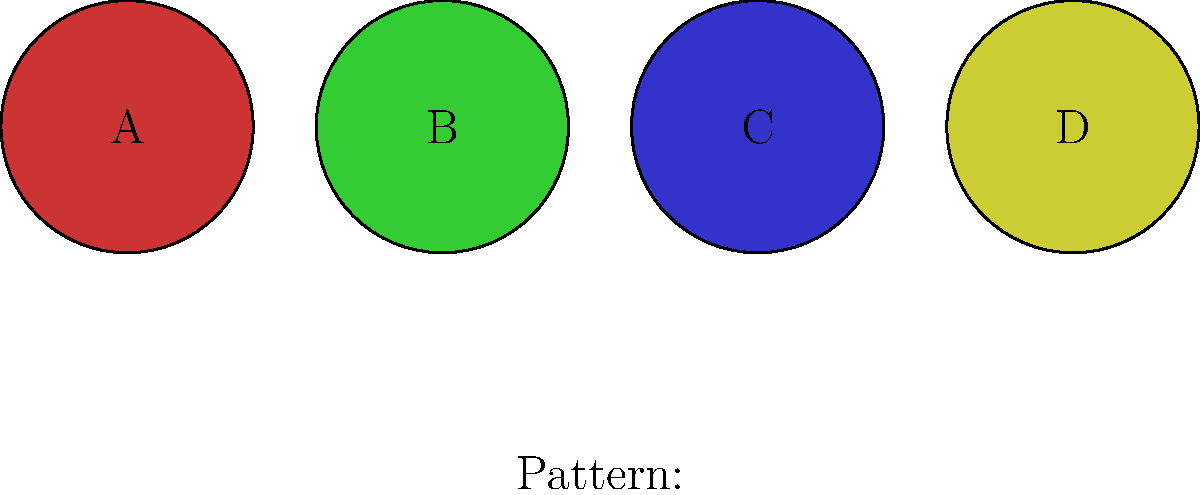As you're designing a new collection for your online boutique, you need to create a striped fabric pattern using the swatches shown above. Which sequence of swatches will produce the pattern shown below the individual swatches? To determine the correct sequence of fabric swatches, we need to analyze the pattern shown and match it with the given swatches:

1. Observe the pattern below the individual swatches. It consists of three vertical stripes.

2. Analyze each stripe in the pattern from left to right:
   - The first stripe is red
   - The second stripe is green
   - The third stripe is blue

3. Match each stripe color with the corresponding swatch:
   - Red stripe matches swatch A
   - Green stripe matches swatch B
   - Blue stripe matches swatch C

4. Arrange the swatches in the order they appear in the pattern:
   A (red) → B (green) → C (blue)

5. Note that swatch D (yellow) is not used in the given pattern.

Therefore, the correct sequence to produce the shown pattern is A, B, C.
Answer: A, B, C 